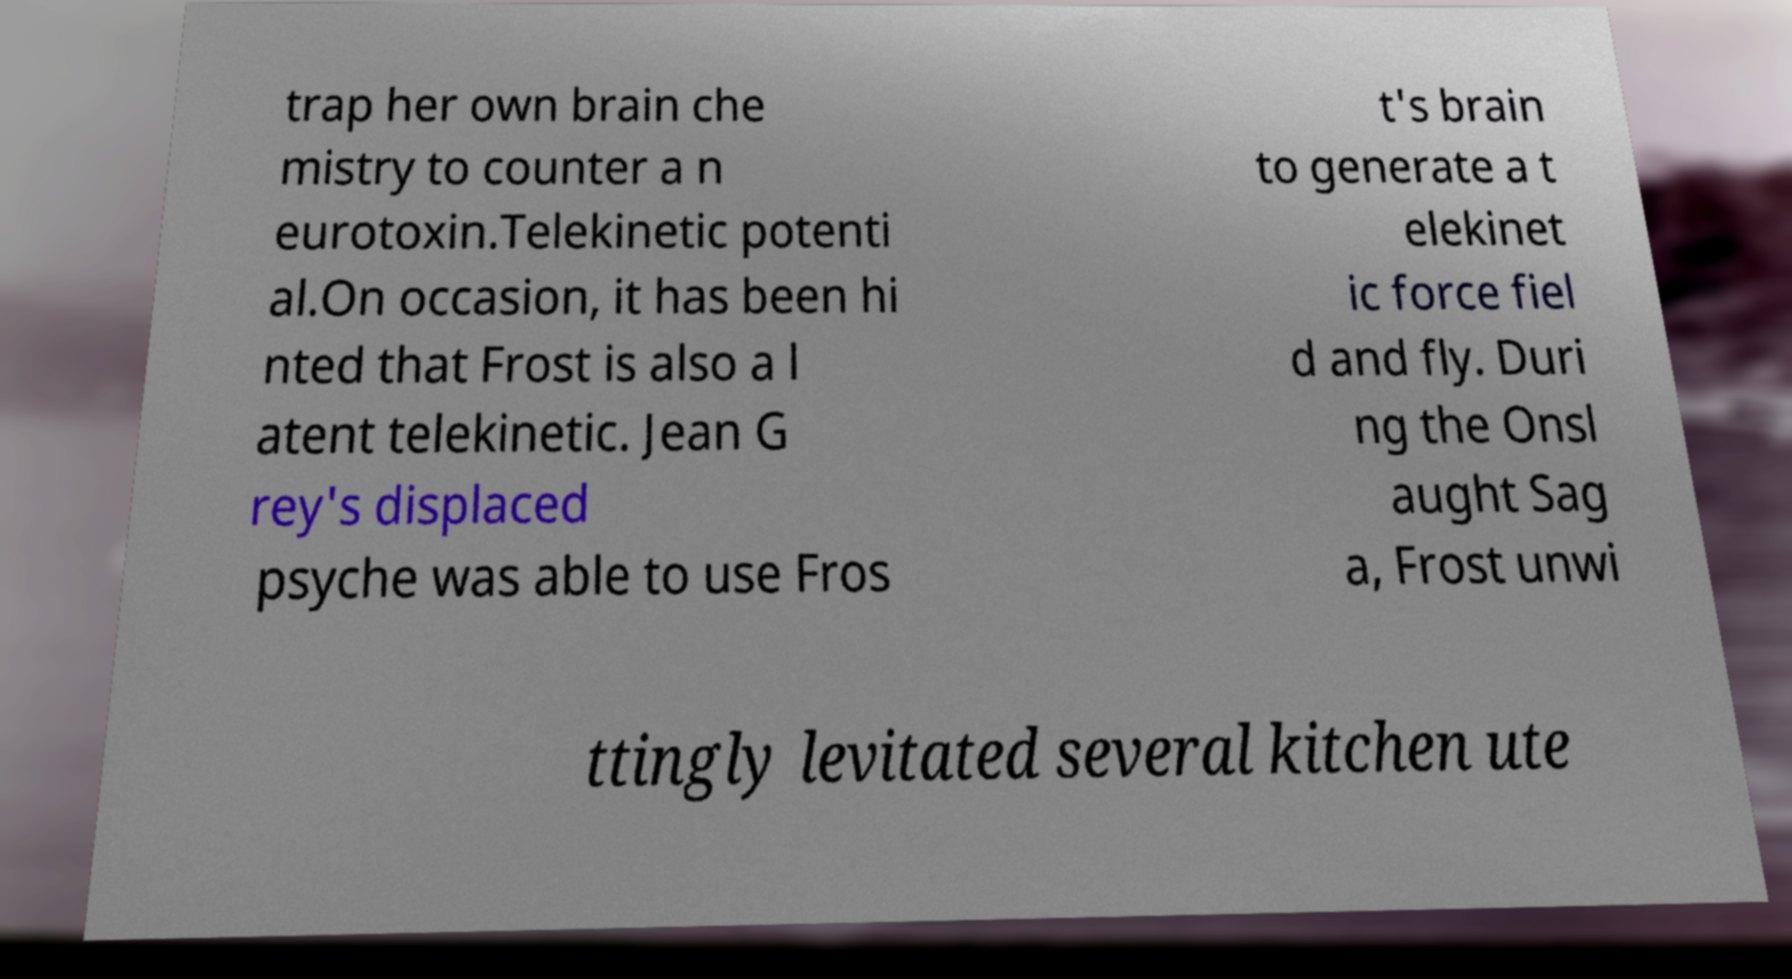Please read and relay the text visible in this image. What does it say? trap her own brain che mistry to counter a n eurotoxin.Telekinetic potenti al.On occasion, it has been hi nted that Frost is also a l atent telekinetic. Jean G rey's displaced psyche was able to use Fros t's brain to generate a t elekinet ic force fiel d and fly. Duri ng the Onsl aught Sag a, Frost unwi ttingly levitated several kitchen ute 